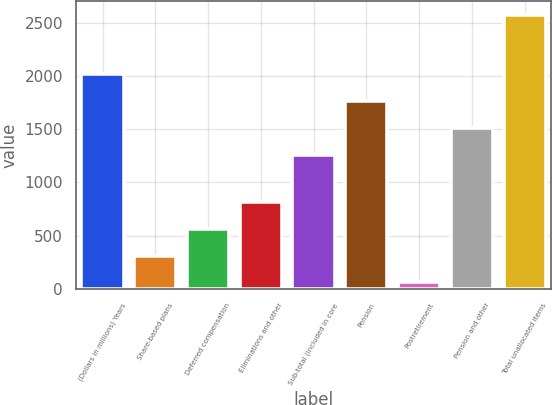<chart> <loc_0><loc_0><loc_500><loc_500><bar_chart><fcel>(Dollars in millions) Years<fcel>Share-based plans<fcel>Deferred compensation<fcel>Eliminations and other<fcel>Sub-total (included in core<fcel>Pension<fcel>Postretirement<fcel>Pension and other<fcel>Total unallocated items<nl><fcel>2015.5<fcel>311.5<fcel>563<fcel>814.5<fcel>1261<fcel>1764<fcel>60<fcel>1512.5<fcel>2575<nl></chart> 